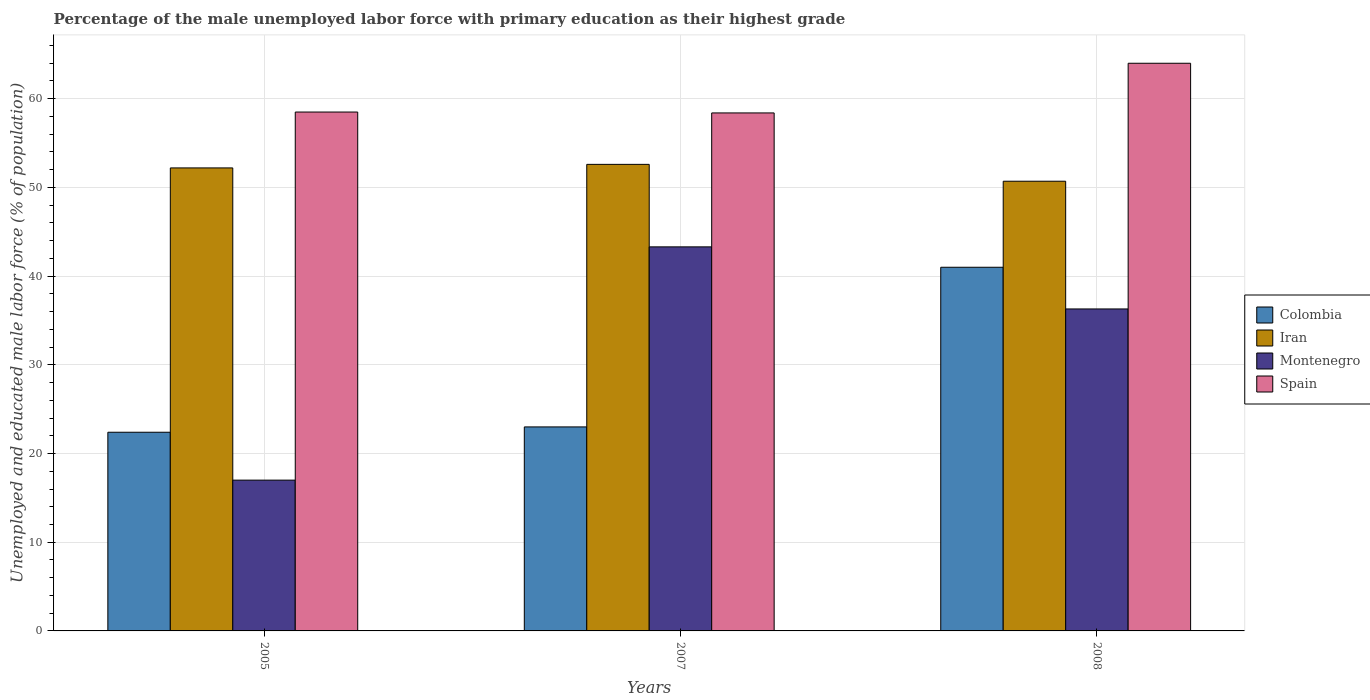Are the number of bars per tick equal to the number of legend labels?
Ensure brevity in your answer.  Yes. What is the label of the 1st group of bars from the left?
Keep it short and to the point. 2005. Across all years, what is the maximum percentage of the unemployed male labor force with primary education in Spain?
Ensure brevity in your answer.  64. Across all years, what is the minimum percentage of the unemployed male labor force with primary education in Iran?
Provide a short and direct response. 50.7. What is the total percentage of the unemployed male labor force with primary education in Colombia in the graph?
Ensure brevity in your answer.  86.4. What is the difference between the percentage of the unemployed male labor force with primary education in Iran in 2005 and that in 2007?
Make the answer very short. -0.4. What is the average percentage of the unemployed male labor force with primary education in Montenegro per year?
Keep it short and to the point. 32.2. In the year 2005, what is the difference between the percentage of the unemployed male labor force with primary education in Montenegro and percentage of the unemployed male labor force with primary education in Iran?
Make the answer very short. -35.2. What is the ratio of the percentage of the unemployed male labor force with primary education in Colombia in 2007 to that in 2008?
Your response must be concise. 0.56. What is the difference between the highest and the lowest percentage of the unemployed male labor force with primary education in Spain?
Provide a succinct answer. 5.6. In how many years, is the percentage of the unemployed male labor force with primary education in Iran greater than the average percentage of the unemployed male labor force with primary education in Iran taken over all years?
Offer a terse response. 2. Is the sum of the percentage of the unemployed male labor force with primary education in Iran in 2005 and 2007 greater than the maximum percentage of the unemployed male labor force with primary education in Colombia across all years?
Ensure brevity in your answer.  Yes. Is it the case that in every year, the sum of the percentage of the unemployed male labor force with primary education in Iran and percentage of the unemployed male labor force with primary education in Spain is greater than the sum of percentage of the unemployed male labor force with primary education in Colombia and percentage of the unemployed male labor force with primary education in Montenegro?
Your answer should be very brief. Yes. What does the 2nd bar from the left in 2008 represents?
Offer a very short reply. Iran. What does the 3rd bar from the right in 2005 represents?
Offer a very short reply. Iran. Is it the case that in every year, the sum of the percentage of the unemployed male labor force with primary education in Iran and percentage of the unemployed male labor force with primary education in Colombia is greater than the percentage of the unemployed male labor force with primary education in Montenegro?
Offer a terse response. Yes. How many bars are there?
Give a very brief answer. 12. Are all the bars in the graph horizontal?
Offer a very short reply. No. What is the difference between two consecutive major ticks on the Y-axis?
Make the answer very short. 10. Are the values on the major ticks of Y-axis written in scientific E-notation?
Offer a terse response. No. Where does the legend appear in the graph?
Provide a short and direct response. Center right. How many legend labels are there?
Your answer should be compact. 4. How are the legend labels stacked?
Provide a short and direct response. Vertical. What is the title of the graph?
Ensure brevity in your answer.  Percentage of the male unemployed labor force with primary education as their highest grade. Does "El Salvador" appear as one of the legend labels in the graph?
Make the answer very short. No. What is the label or title of the X-axis?
Your answer should be compact. Years. What is the label or title of the Y-axis?
Keep it short and to the point. Unemployed and educated male labor force (% of population). What is the Unemployed and educated male labor force (% of population) in Colombia in 2005?
Provide a succinct answer. 22.4. What is the Unemployed and educated male labor force (% of population) in Iran in 2005?
Ensure brevity in your answer.  52.2. What is the Unemployed and educated male labor force (% of population) of Montenegro in 2005?
Keep it short and to the point. 17. What is the Unemployed and educated male labor force (% of population) of Spain in 2005?
Offer a very short reply. 58.5. What is the Unemployed and educated male labor force (% of population) of Colombia in 2007?
Offer a terse response. 23. What is the Unemployed and educated male labor force (% of population) in Iran in 2007?
Your response must be concise. 52.6. What is the Unemployed and educated male labor force (% of population) of Montenegro in 2007?
Your answer should be very brief. 43.3. What is the Unemployed and educated male labor force (% of population) of Spain in 2007?
Ensure brevity in your answer.  58.4. What is the Unemployed and educated male labor force (% of population) in Colombia in 2008?
Provide a succinct answer. 41. What is the Unemployed and educated male labor force (% of population) of Iran in 2008?
Offer a terse response. 50.7. What is the Unemployed and educated male labor force (% of population) of Montenegro in 2008?
Offer a terse response. 36.3. Across all years, what is the maximum Unemployed and educated male labor force (% of population) in Colombia?
Provide a short and direct response. 41. Across all years, what is the maximum Unemployed and educated male labor force (% of population) of Iran?
Your response must be concise. 52.6. Across all years, what is the maximum Unemployed and educated male labor force (% of population) of Montenegro?
Give a very brief answer. 43.3. Across all years, what is the minimum Unemployed and educated male labor force (% of population) of Colombia?
Your answer should be very brief. 22.4. Across all years, what is the minimum Unemployed and educated male labor force (% of population) in Iran?
Your response must be concise. 50.7. Across all years, what is the minimum Unemployed and educated male labor force (% of population) in Montenegro?
Keep it short and to the point. 17. Across all years, what is the minimum Unemployed and educated male labor force (% of population) in Spain?
Provide a succinct answer. 58.4. What is the total Unemployed and educated male labor force (% of population) in Colombia in the graph?
Offer a terse response. 86.4. What is the total Unemployed and educated male labor force (% of population) in Iran in the graph?
Provide a succinct answer. 155.5. What is the total Unemployed and educated male labor force (% of population) of Montenegro in the graph?
Provide a succinct answer. 96.6. What is the total Unemployed and educated male labor force (% of population) in Spain in the graph?
Provide a short and direct response. 180.9. What is the difference between the Unemployed and educated male labor force (% of population) in Colombia in 2005 and that in 2007?
Ensure brevity in your answer.  -0.6. What is the difference between the Unemployed and educated male labor force (% of population) in Montenegro in 2005 and that in 2007?
Provide a succinct answer. -26.3. What is the difference between the Unemployed and educated male labor force (% of population) in Colombia in 2005 and that in 2008?
Keep it short and to the point. -18.6. What is the difference between the Unemployed and educated male labor force (% of population) in Montenegro in 2005 and that in 2008?
Your response must be concise. -19.3. What is the difference between the Unemployed and educated male labor force (% of population) in Montenegro in 2007 and that in 2008?
Your answer should be compact. 7. What is the difference between the Unemployed and educated male labor force (% of population) of Spain in 2007 and that in 2008?
Your answer should be very brief. -5.6. What is the difference between the Unemployed and educated male labor force (% of population) of Colombia in 2005 and the Unemployed and educated male labor force (% of population) of Iran in 2007?
Provide a short and direct response. -30.2. What is the difference between the Unemployed and educated male labor force (% of population) of Colombia in 2005 and the Unemployed and educated male labor force (% of population) of Montenegro in 2007?
Provide a succinct answer. -20.9. What is the difference between the Unemployed and educated male labor force (% of population) in Colombia in 2005 and the Unemployed and educated male labor force (% of population) in Spain in 2007?
Your response must be concise. -36. What is the difference between the Unemployed and educated male labor force (% of population) in Iran in 2005 and the Unemployed and educated male labor force (% of population) in Montenegro in 2007?
Provide a succinct answer. 8.9. What is the difference between the Unemployed and educated male labor force (% of population) in Iran in 2005 and the Unemployed and educated male labor force (% of population) in Spain in 2007?
Your response must be concise. -6.2. What is the difference between the Unemployed and educated male labor force (% of population) in Montenegro in 2005 and the Unemployed and educated male labor force (% of population) in Spain in 2007?
Ensure brevity in your answer.  -41.4. What is the difference between the Unemployed and educated male labor force (% of population) of Colombia in 2005 and the Unemployed and educated male labor force (% of population) of Iran in 2008?
Your response must be concise. -28.3. What is the difference between the Unemployed and educated male labor force (% of population) in Colombia in 2005 and the Unemployed and educated male labor force (% of population) in Spain in 2008?
Keep it short and to the point. -41.6. What is the difference between the Unemployed and educated male labor force (% of population) of Montenegro in 2005 and the Unemployed and educated male labor force (% of population) of Spain in 2008?
Provide a succinct answer. -47. What is the difference between the Unemployed and educated male labor force (% of population) in Colombia in 2007 and the Unemployed and educated male labor force (% of population) in Iran in 2008?
Offer a very short reply. -27.7. What is the difference between the Unemployed and educated male labor force (% of population) of Colombia in 2007 and the Unemployed and educated male labor force (% of population) of Spain in 2008?
Your response must be concise. -41. What is the difference between the Unemployed and educated male labor force (% of population) in Iran in 2007 and the Unemployed and educated male labor force (% of population) in Spain in 2008?
Make the answer very short. -11.4. What is the difference between the Unemployed and educated male labor force (% of population) of Montenegro in 2007 and the Unemployed and educated male labor force (% of population) of Spain in 2008?
Your answer should be compact. -20.7. What is the average Unemployed and educated male labor force (% of population) in Colombia per year?
Keep it short and to the point. 28.8. What is the average Unemployed and educated male labor force (% of population) in Iran per year?
Ensure brevity in your answer.  51.83. What is the average Unemployed and educated male labor force (% of population) in Montenegro per year?
Give a very brief answer. 32.2. What is the average Unemployed and educated male labor force (% of population) of Spain per year?
Your answer should be very brief. 60.3. In the year 2005, what is the difference between the Unemployed and educated male labor force (% of population) in Colombia and Unemployed and educated male labor force (% of population) in Iran?
Ensure brevity in your answer.  -29.8. In the year 2005, what is the difference between the Unemployed and educated male labor force (% of population) of Colombia and Unemployed and educated male labor force (% of population) of Montenegro?
Offer a very short reply. 5.4. In the year 2005, what is the difference between the Unemployed and educated male labor force (% of population) in Colombia and Unemployed and educated male labor force (% of population) in Spain?
Your answer should be very brief. -36.1. In the year 2005, what is the difference between the Unemployed and educated male labor force (% of population) in Iran and Unemployed and educated male labor force (% of population) in Montenegro?
Your answer should be very brief. 35.2. In the year 2005, what is the difference between the Unemployed and educated male labor force (% of population) in Iran and Unemployed and educated male labor force (% of population) in Spain?
Keep it short and to the point. -6.3. In the year 2005, what is the difference between the Unemployed and educated male labor force (% of population) in Montenegro and Unemployed and educated male labor force (% of population) in Spain?
Offer a terse response. -41.5. In the year 2007, what is the difference between the Unemployed and educated male labor force (% of population) in Colombia and Unemployed and educated male labor force (% of population) in Iran?
Keep it short and to the point. -29.6. In the year 2007, what is the difference between the Unemployed and educated male labor force (% of population) in Colombia and Unemployed and educated male labor force (% of population) in Montenegro?
Provide a succinct answer. -20.3. In the year 2007, what is the difference between the Unemployed and educated male labor force (% of population) of Colombia and Unemployed and educated male labor force (% of population) of Spain?
Provide a short and direct response. -35.4. In the year 2007, what is the difference between the Unemployed and educated male labor force (% of population) in Iran and Unemployed and educated male labor force (% of population) in Spain?
Provide a short and direct response. -5.8. In the year 2007, what is the difference between the Unemployed and educated male labor force (% of population) in Montenegro and Unemployed and educated male labor force (% of population) in Spain?
Your answer should be compact. -15.1. In the year 2008, what is the difference between the Unemployed and educated male labor force (% of population) of Colombia and Unemployed and educated male labor force (% of population) of Iran?
Your response must be concise. -9.7. In the year 2008, what is the difference between the Unemployed and educated male labor force (% of population) in Colombia and Unemployed and educated male labor force (% of population) in Spain?
Your response must be concise. -23. In the year 2008, what is the difference between the Unemployed and educated male labor force (% of population) of Iran and Unemployed and educated male labor force (% of population) of Montenegro?
Provide a short and direct response. 14.4. In the year 2008, what is the difference between the Unemployed and educated male labor force (% of population) in Montenegro and Unemployed and educated male labor force (% of population) in Spain?
Keep it short and to the point. -27.7. What is the ratio of the Unemployed and educated male labor force (% of population) of Colombia in 2005 to that in 2007?
Make the answer very short. 0.97. What is the ratio of the Unemployed and educated male labor force (% of population) of Montenegro in 2005 to that in 2007?
Make the answer very short. 0.39. What is the ratio of the Unemployed and educated male labor force (% of population) of Colombia in 2005 to that in 2008?
Ensure brevity in your answer.  0.55. What is the ratio of the Unemployed and educated male labor force (% of population) in Iran in 2005 to that in 2008?
Your response must be concise. 1.03. What is the ratio of the Unemployed and educated male labor force (% of population) of Montenegro in 2005 to that in 2008?
Give a very brief answer. 0.47. What is the ratio of the Unemployed and educated male labor force (% of population) of Spain in 2005 to that in 2008?
Your answer should be very brief. 0.91. What is the ratio of the Unemployed and educated male labor force (% of population) in Colombia in 2007 to that in 2008?
Your response must be concise. 0.56. What is the ratio of the Unemployed and educated male labor force (% of population) in Iran in 2007 to that in 2008?
Keep it short and to the point. 1.04. What is the ratio of the Unemployed and educated male labor force (% of population) of Montenegro in 2007 to that in 2008?
Make the answer very short. 1.19. What is the ratio of the Unemployed and educated male labor force (% of population) in Spain in 2007 to that in 2008?
Provide a succinct answer. 0.91. What is the difference between the highest and the second highest Unemployed and educated male labor force (% of population) in Spain?
Offer a terse response. 5.5. What is the difference between the highest and the lowest Unemployed and educated male labor force (% of population) of Colombia?
Offer a terse response. 18.6. What is the difference between the highest and the lowest Unemployed and educated male labor force (% of population) in Iran?
Make the answer very short. 1.9. What is the difference between the highest and the lowest Unemployed and educated male labor force (% of population) of Montenegro?
Provide a short and direct response. 26.3. What is the difference between the highest and the lowest Unemployed and educated male labor force (% of population) of Spain?
Make the answer very short. 5.6. 